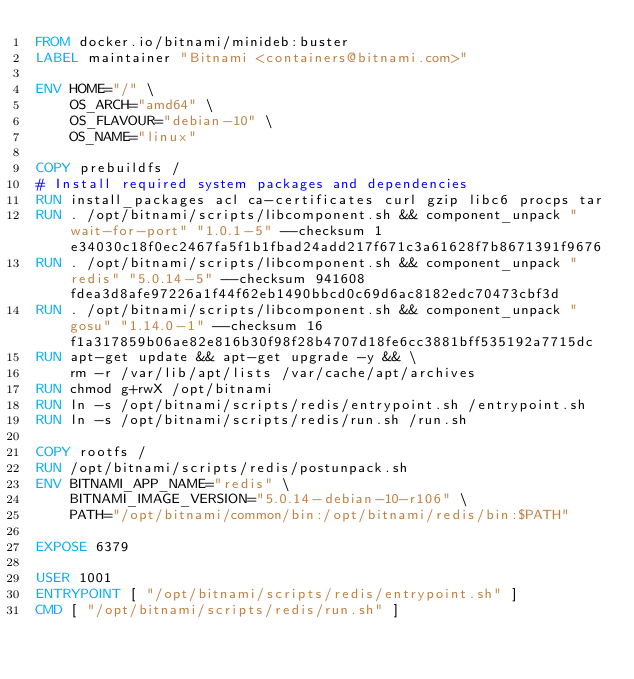Convert code to text. <code><loc_0><loc_0><loc_500><loc_500><_Dockerfile_>FROM docker.io/bitnami/minideb:buster
LABEL maintainer "Bitnami <containers@bitnami.com>"

ENV HOME="/" \
    OS_ARCH="amd64" \
    OS_FLAVOUR="debian-10" \
    OS_NAME="linux"

COPY prebuildfs /
# Install required system packages and dependencies
RUN install_packages acl ca-certificates curl gzip libc6 procps tar
RUN . /opt/bitnami/scripts/libcomponent.sh && component_unpack "wait-for-port" "1.0.1-5" --checksum 1e34030c18f0ec2467fa5f1b1fbad24add217f671c3a61628f7b8671391f9676
RUN . /opt/bitnami/scripts/libcomponent.sh && component_unpack "redis" "5.0.14-5" --checksum 941608fdea3d8afe97226a1f44f62eb1490bbcd0c69d6ac8182edc70473cbf3d
RUN . /opt/bitnami/scripts/libcomponent.sh && component_unpack "gosu" "1.14.0-1" --checksum 16f1a317859b06ae82e816b30f98f28b4707d18fe6cc3881bff535192a7715dc
RUN apt-get update && apt-get upgrade -y && \
    rm -r /var/lib/apt/lists /var/cache/apt/archives
RUN chmod g+rwX /opt/bitnami
RUN ln -s /opt/bitnami/scripts/redis/entrypoint.sh /entrypoint.sh
RUN ln -s /opt/bitnami/scripts/redis/run.sh /run.sh

COPY rootfs /
RUN /opt/bitnami/scripts/redis/postunpack.sh
ENV BITNAMI_APP_NAME="redis" \
    BITNAMI_IMAGE_VERSION="5.0.14-debian-10-r106" \
    PATH="/opt/bitnami/common/bin:/opt/bitnami/redis/bin:$PATH"

EXPOSE 6379

USER 1001
ENTRYPOINT [ "/opt/bitnami/scripts/redis/entrypoint.sh" ]
CMD [ "/opt/bitnami/scripts/redis/run.sh" ]
</code> 